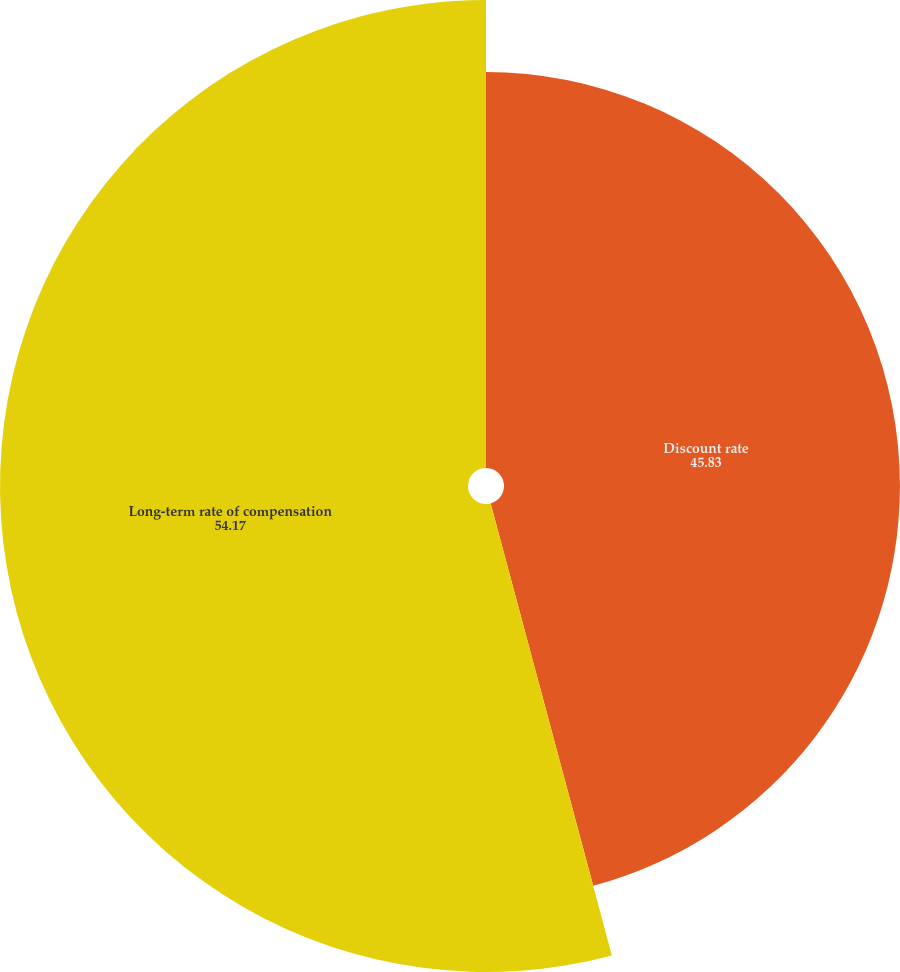<chart> <loc_0><loc_0><loc_500><loc_500><pie_chart><fcel>Discount rate<fcel>Long-term rate of compensation<nl><fcel>45.83%<fcel>54.17%<nl></chart> 